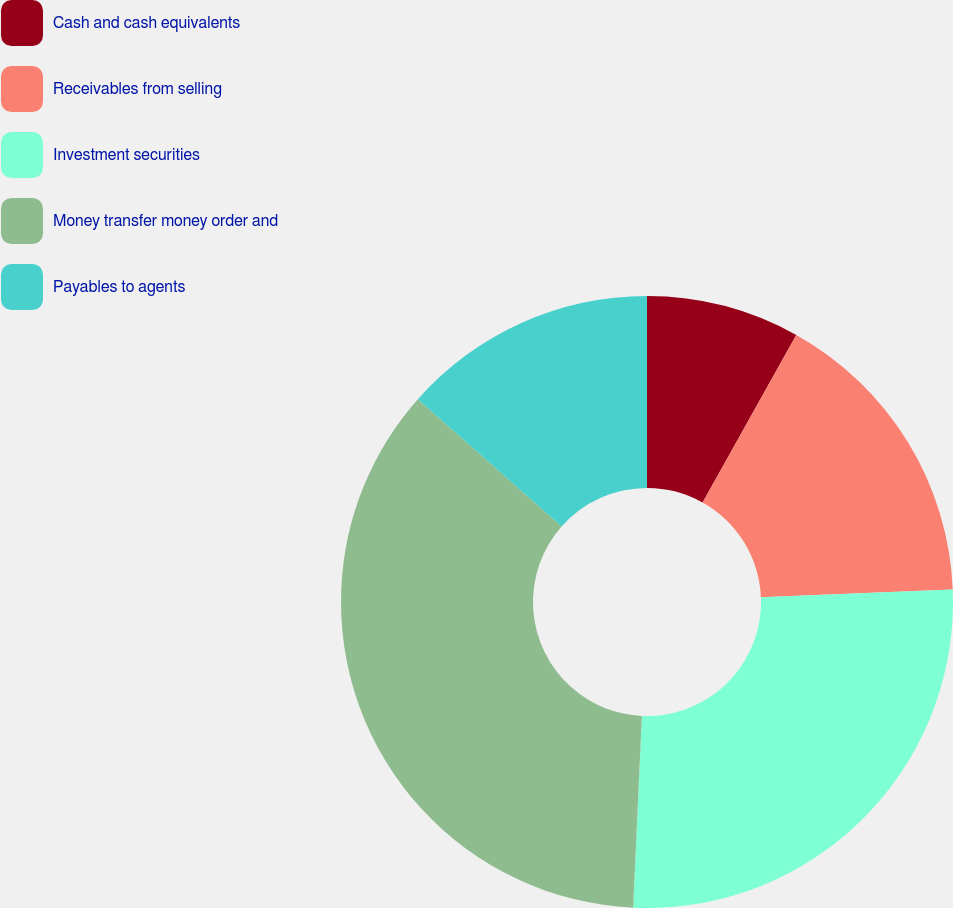Convert chart. <chart><loc_0><loc_0><loc_500><loc_500><pie_chart><fcel>Cash and cash equivalents<fcel>Receivables from selling<fcel>Investment securities<fcel>Money transfer money order and<fcel>Payables to agents<nl><fcel>8.11%<fcel>16.24%<fcel>26.37%<fcel>35.81%<fcel>13.47%<nl></chart> 